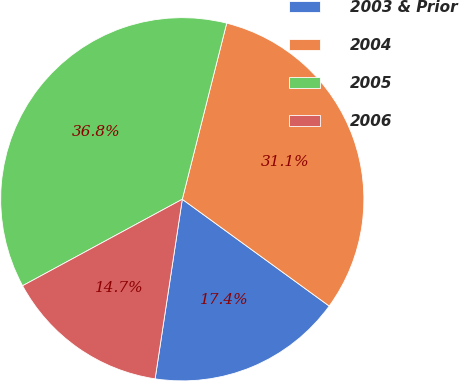Convert chart. <chart><loc_0><loc_0><loc_500><loc_500><pie_chart><fcel>2003 & Prior<fcel>2004<fcel>2005<fcel>2006<nl><fcel>17.39%<fcel>31.07%<fcel>36.83%<fcel>14.71%<nl></chart> 